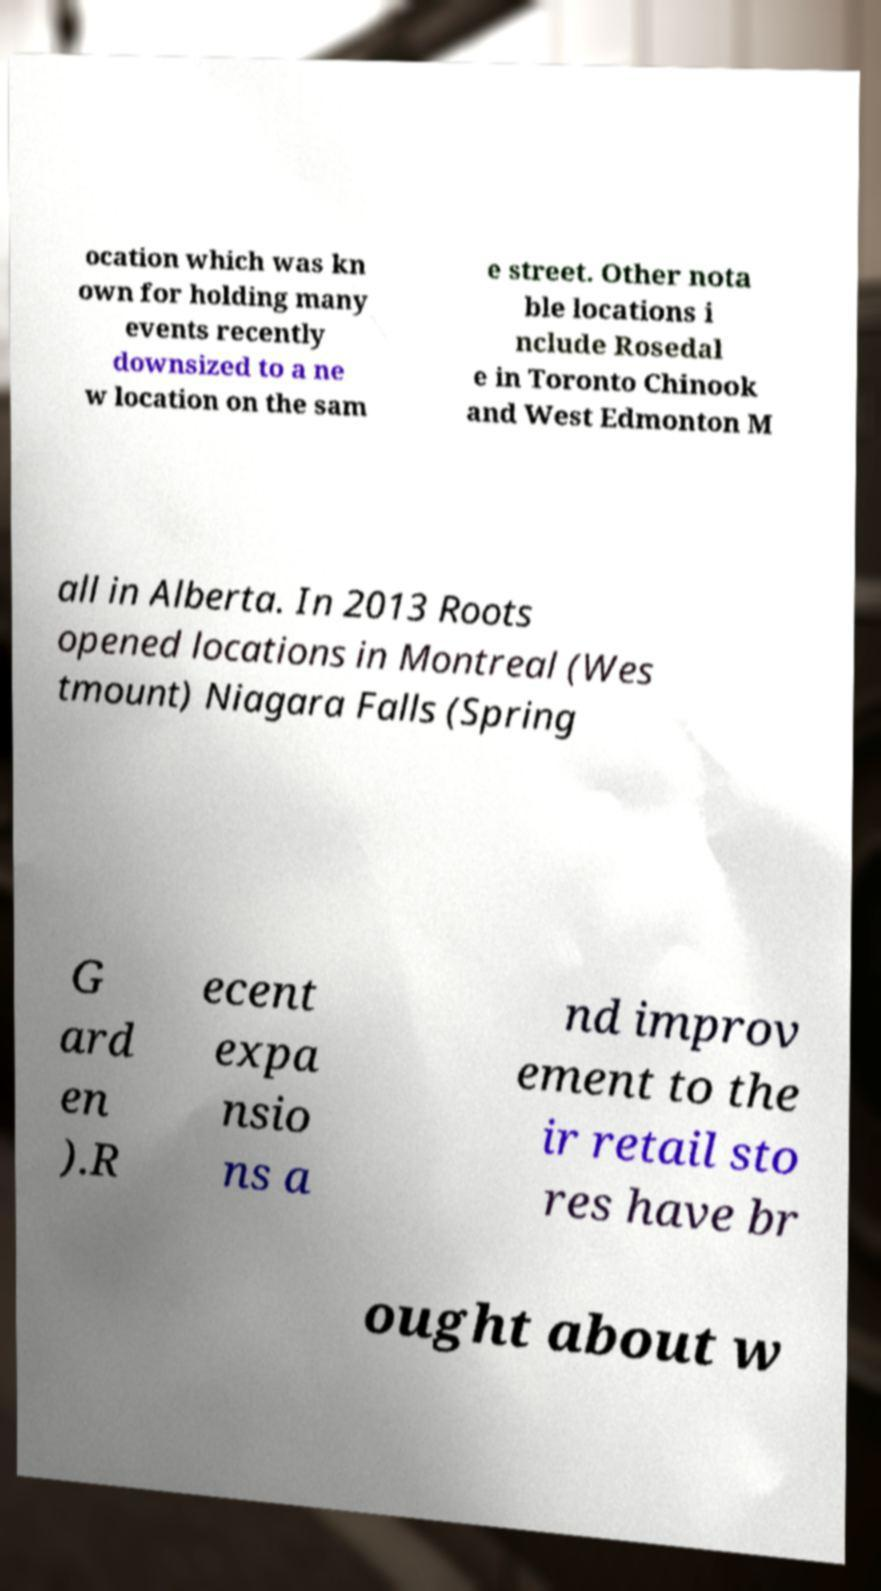Please identify and transcribe the text found in this image. ocation which was kn own for holding many events recently downsized to a ne w location on the sam e street. Other nota ble locations i nclude Rosedal e in Toronto Chinook and West Edmonton M all in Alberta. In 2013 Roots opened locations in Montreal (Wes tmount) Niagara Falls (Spring G ard en ).R ecent expa nsio ns a nd improv ement to the ir retail sto res have br ought about w 